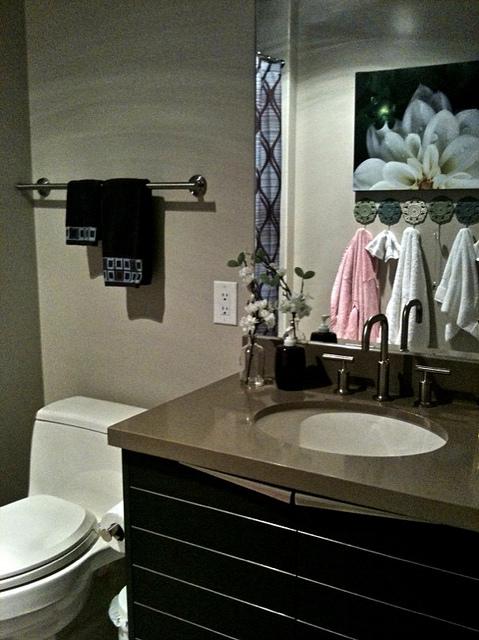What color is the sink under the mirror?
Give a very brief answer. White. Is this bathroom masculine?
Be succinct. No. Would this bathroom style be described as modern?
Write a very short answer. Yes. How many towels are visible?
Keep it brief. 5. How many hand towels do you see?
Give a very brief answer. 5. What color is the towel above the toilet?
Keep it brief. Black. 